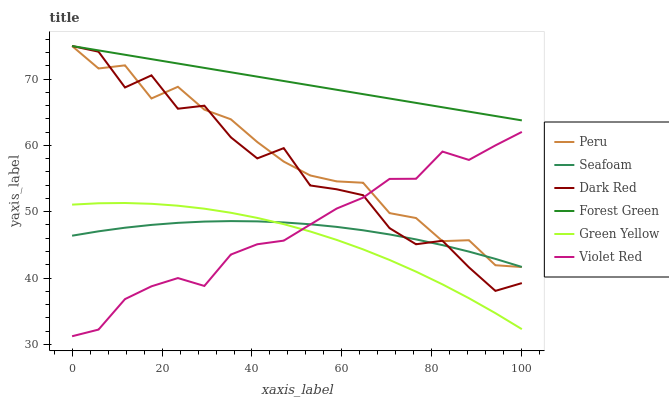Does Dark Red have the minimum area under the curve?
Answer yes or no. No. Does Dark Red have the maximum area under the curve?
Answer yes or no. No. Is Seafoam the smoothest?
Answer yes or no. No. Is Seafoam the roughest?
Answer yes or no. No. Does Dark Red have the lowest value?
Answer yes or no. No. Does Seafoam have the highest value?
Answer yes or no. No. Is Seafoam less than Forest Green?
Answer yes or no. Yes. Is Forest Green greater than Green Yellow?
Answer yes or no. Yes. Does Seafoam intersect Forest Green?
Answer yes or no. No. 